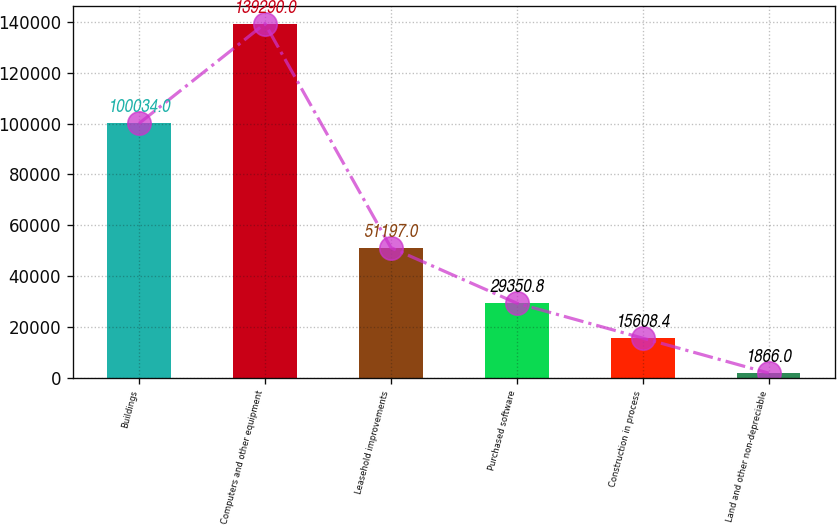Convert chart. <chart><loc_0><loc_0><loc_500><loc_500><bar_chart><fcel>Buildings<fcel>Computers and other equipment<fcel>Leasehold improvements<fcel>Purchased software<fcel>Construction in process<fcel>Land and other non-depreciable<nl><fcel>100034<fcel>139290<fcel>51197<fcel>29350.8<fcel>15608.4<fcel>1866<nl></chart> 